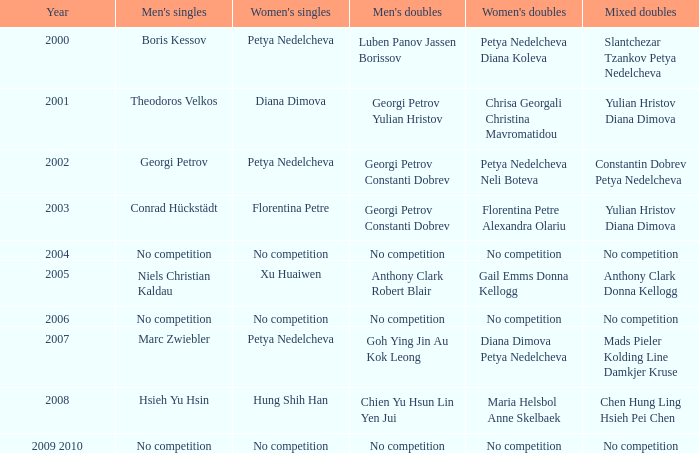During what year was a competition for women absent? 2004, 2006, 2009 2010. 